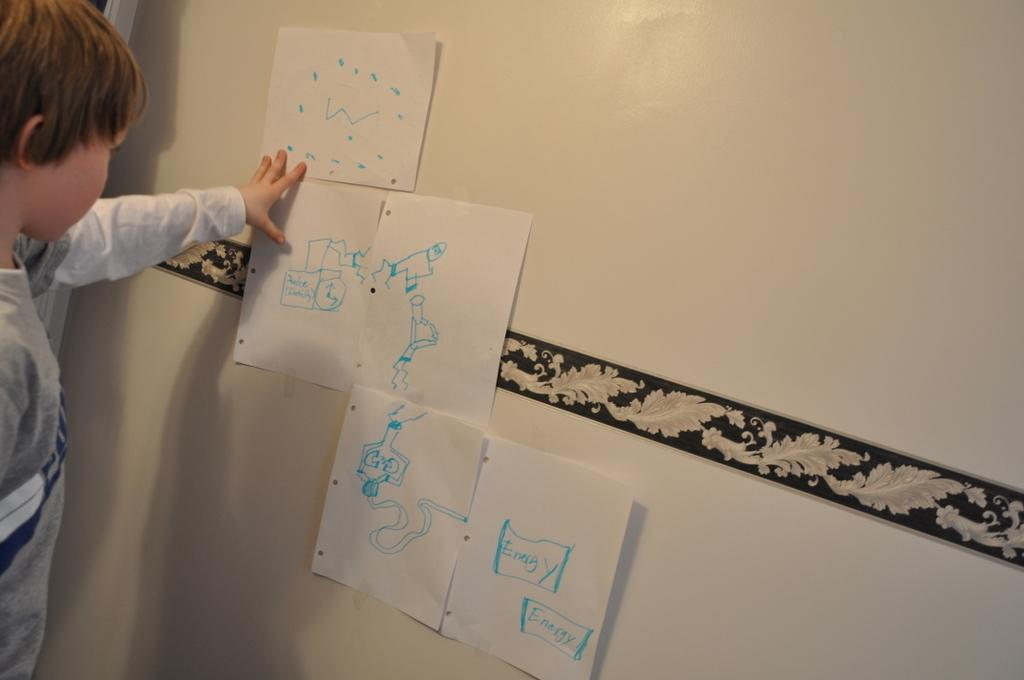<image>
Present a compact description of the photo's key features. A boy holding up pieces of paper and the writing "energy". 